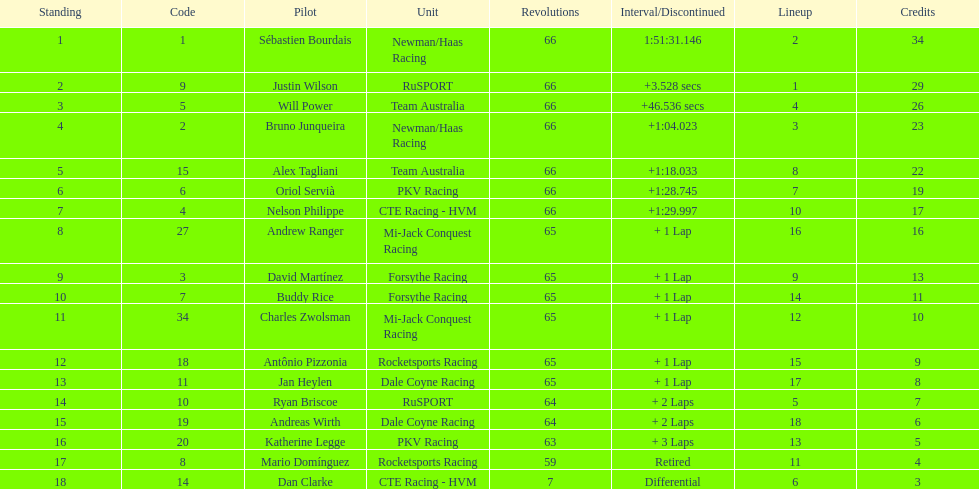How many laps did oriol servia complete at the 2006 gran premio? 66. How many laps did katherine legge complete at the 2006 gran premio? 63. Between servia and legge, who completed more laps? Oriol Servià. Can you give me this table as a dict? {'header': ['Standing', 'Code', 'Pilot', 'Unit', 'Revolutions', 'Interval/Discontinued', 'Lineup', 'Credits'], 'rows': [['1', '1', 'Sébastien Bourdais', 'Newman/Haas Racing', '66', '1:51:31.146', '2', '34'], ['2', '9', 'Justin Wilson', 'RuSPORT', '66', '+3.528 secs', '1', '29'], ['3', '5', 'Will Power', 'Team Australia', '66', '+46.536 secs', '4', '26'], ['4', '2', 'Bruno Junqueira', 'Newman/Haas Racing', '66', '+1:04.023', '3', '23'], ['5', '15', 'Alex Tagliani', 'Team Australia', '66', '+1:18.033', '8', '22'], ['6', '6', 'Oriol Servià', 'PKV Racing', '66', '+1:28.745', '7', '19'], ['7', '4', 'Nelson Philippe', 'CTE Racing - HVM', '66', '+1:29.997', '10', '17'], ['8', '27', 'Andrew Ranger', 'Mi-Jack Conquest Racing', '65', '+ 1 Lap', '16', '16'], ['9', '3', 'David Martínez', 'Forsythe Racing', '65', '+ 1 Lap', '9', '13'], ['10', '7', 'Buddy Rice', 'Forsythe Racing', '65', '+ 1 Lap', '14', '11'], ['11', '34', 'Charles Zwolsman', 'Mi-Jack Conquest Racing', '65', '+ 1 Lap', '12', '10'], ['12', '18', 'Antônio Pizzonia', 'Rocketsports Racing', '65', '+ 1 Lap', '15', '9'], ['13', '11', 'Jan Heylen', 'Dale Coyne Racing', '65', '+ 1 Lap', '17', '8'], ['14', '10', 'Ryan Briscoe', 'RuSPORT', '64', '+ 2 Laps', '5', '7'], ['15', '19', 'Andreas Wirth', 'Dale Coyne Racing', '64', '+ 2 Laps', '18', '6'], ['16', '20', 'Katherine Legge', 'PKV Racing', '63', '+ 3 Laps', '13', '5'], ['17', '8', 'Mario Domínguez', 'Rocketsports Racing', '59', 'Retired', '11', '4'], ['18', '14', 'Dan Clarke', 'CTE Racing - HVM', '7', 'Differential', '6', '3']]} 